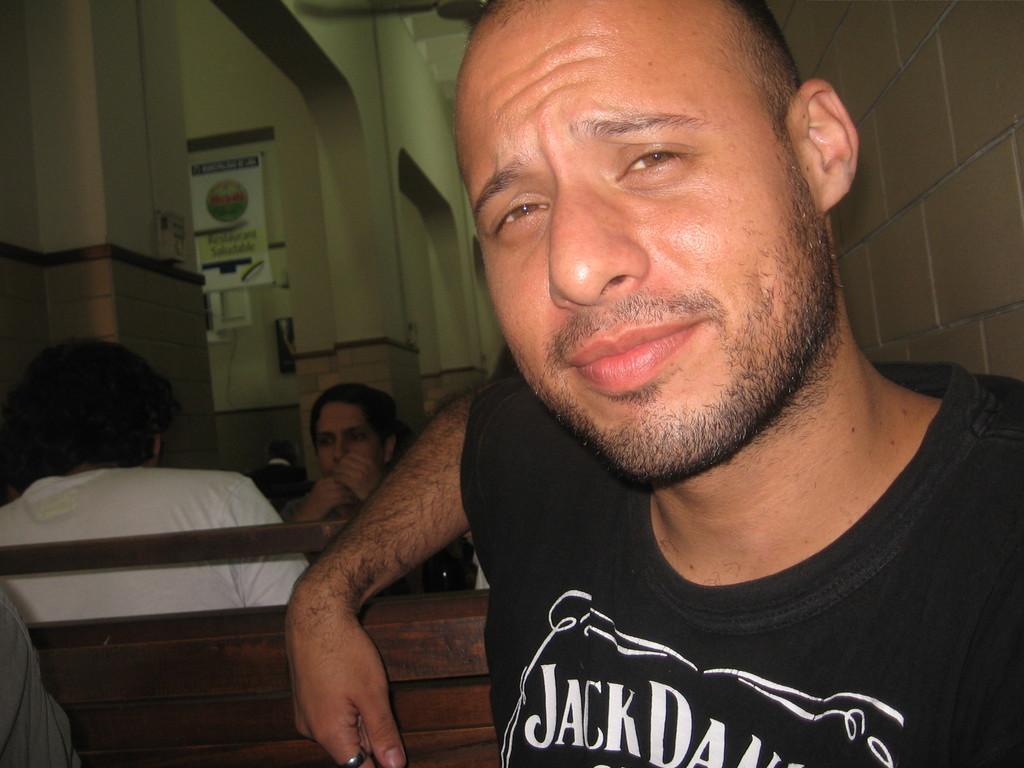Could you give a brief overview of what you see in this image? In this picture I can see a man sitting, there are few people sitting, and in the background there is a board, fan and there are walls. 